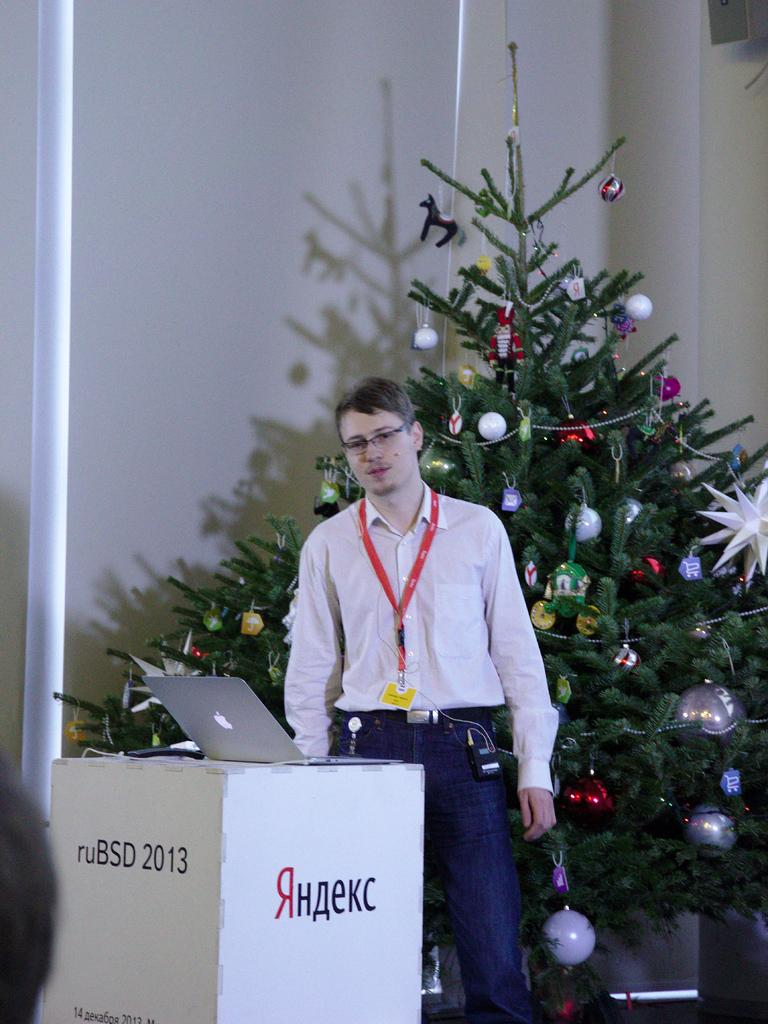<image>
Summarize the visual content of the image. A man wearing a white shirt is standing in front of a podium with a sign "ruBSD 2013". 